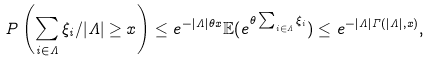Convert formula to latex. <formula><loc_0><loc_0><loc_500><loc_500>P \left ( \sum _ { i \in \Lambda } \xi _ { i } / | \Lambda | \geq x \right ) \leq e ^ { - | \Lambda | \theta x } { \mathbb { E } } ( e ^ { \theta \sum _ { i \in \Lambda } \xi _ { i } } ) \leq e ^ { - | \Lambda | \Gamma ( | \Lambda | , x ) } ,</formula> 